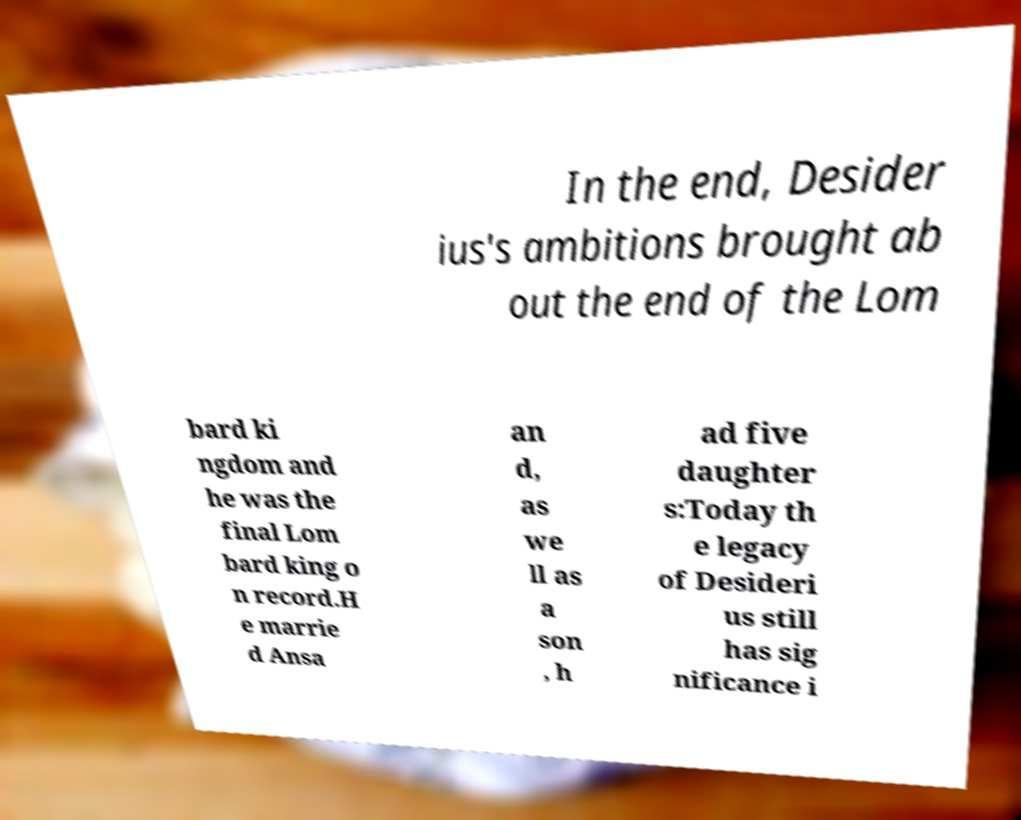Please read and relay the text visible in this image. What does it say? In the end, Desider ius's ambitions brought ab out the end of the Lom bard ki ngdom and he was the final Lom bard king o n record.H e marrie d Ansa an d, as we ll as a son , h ad five daughter s:Today th e legacy of Desideri us still has sig nificance i 